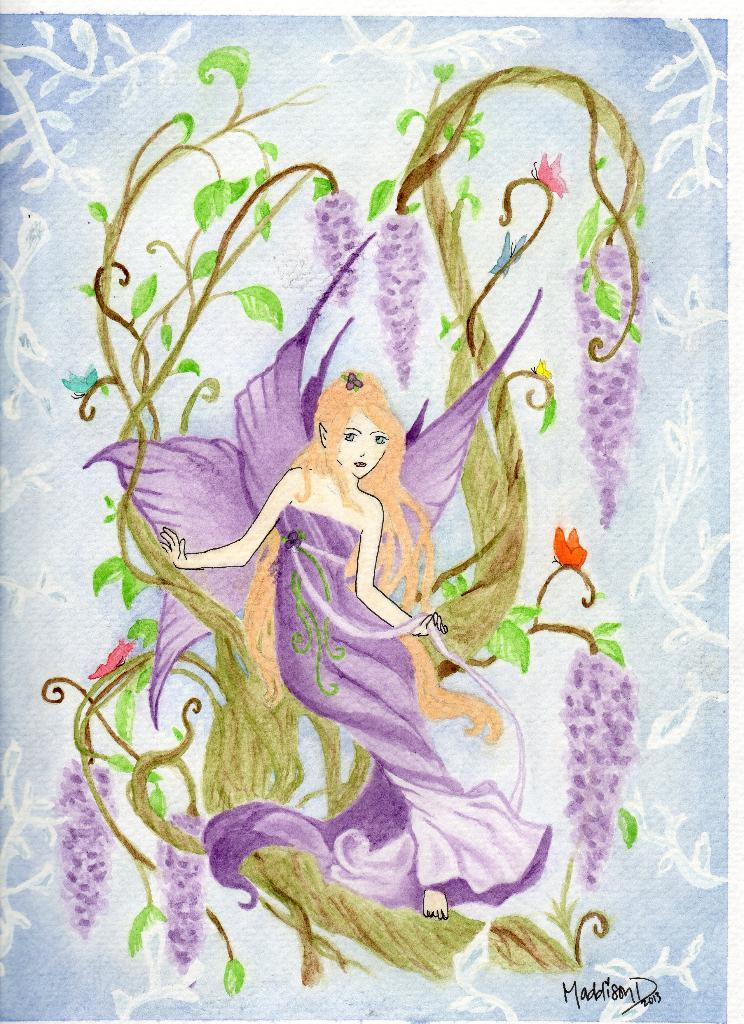What is the main subject of the painting in the image? The painting features a fairy sitting on a swing. What is depicted on the swing in the painting? The swing has flowers and leaves. Is there any text associated with the painting in the image? Yes, there is text at the bottom of the painting. Can you tell me how many basketballs are in the painting? There are no basketballs present in the painting; it features a fairy sitting on a swing with flowers and leaves. What type of twist is depicted in the painting? There is no twist depicted in the painting; it features a fairy sitting on a swing with flowers and leaves, and text at the bottom. 